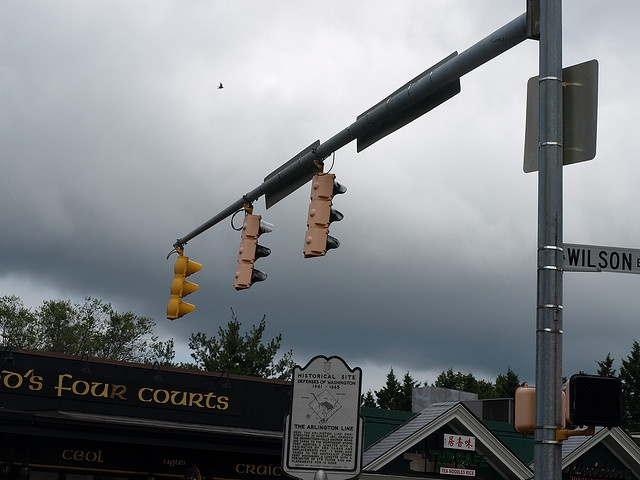Describe the objects in this image and their specific colors. I can see traffic light in lightgray, gray, and black tones, traffic light in lightgray, gray, black, and brown tones, traffic light in lightgray, olive, maroon, and gray tones, and bird in lightgray, darkgray, black, and gray tones in this image. 